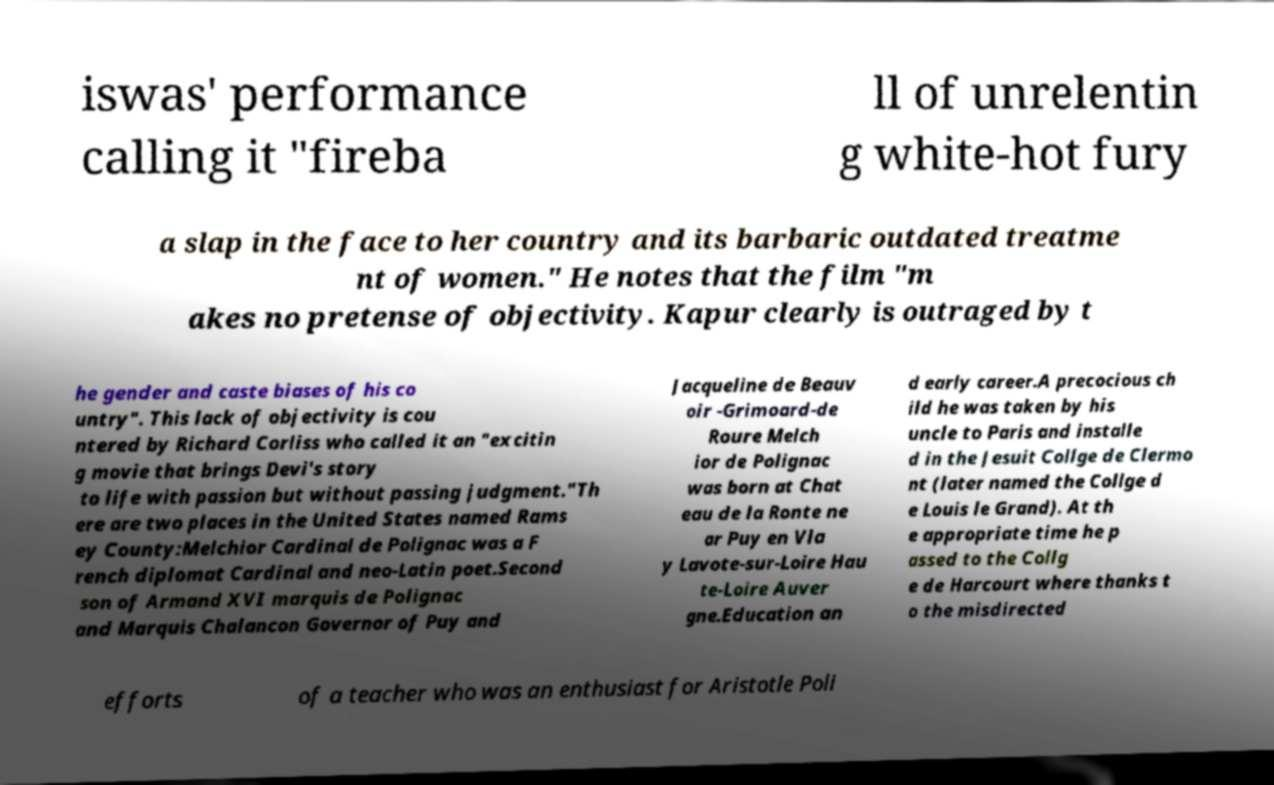What messages or text are displayed in this image? I need them in a readable, typed format. iswas' performance calling it "fireba ll of unrelentin g white-hot fury a slap in the face to her country and its barbaric outdated treatme nt of women." He notes that the film "m akes no pretense of objectivity. Kapur clearly is outraged by t he gender and caste biases of his co untry". This lack of objectivity is cou ntered by Richard Corliss who called it an "excitin g movie that brings Devi's story to life with passion but without passing judgment."Th ere are two places in the United States named Rams ey County:Melchior Cardinal de Polignac was a F rench diplomat Cardinal and neo-Latin poet.Second son of Armand XVI marquis de Polignac and Marquis Chalancon Governor of Puy and Jacqueline de Beauv oir -Grimoard-de Roure Melch ior de Polignac was born at Chat eau de la Ronte ne ar Puy en Vla y Lavote-sur-Loire Hau te-Loire Auver gne.Education an d early career.A precocious ch ild he was taken by his uncle to Paris and installe d in the Jesuit Collge de Clermo nt (later named the Collge d e Louis le Grand). At th e appropriate time he p assed to the Collg e de Harcourt where thanks t o the misdirected efforts of a teacher who was an enthusiast for Aristotle Poli 